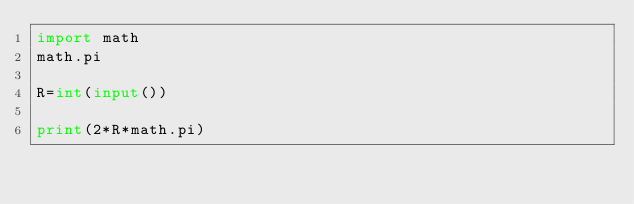Convert code to text. <code><loc_0><loc_0><loc_500><loc_500><_Python_>import math
math.pi
  
R=int(input())
     
print(2*R*math.pi)</code> 